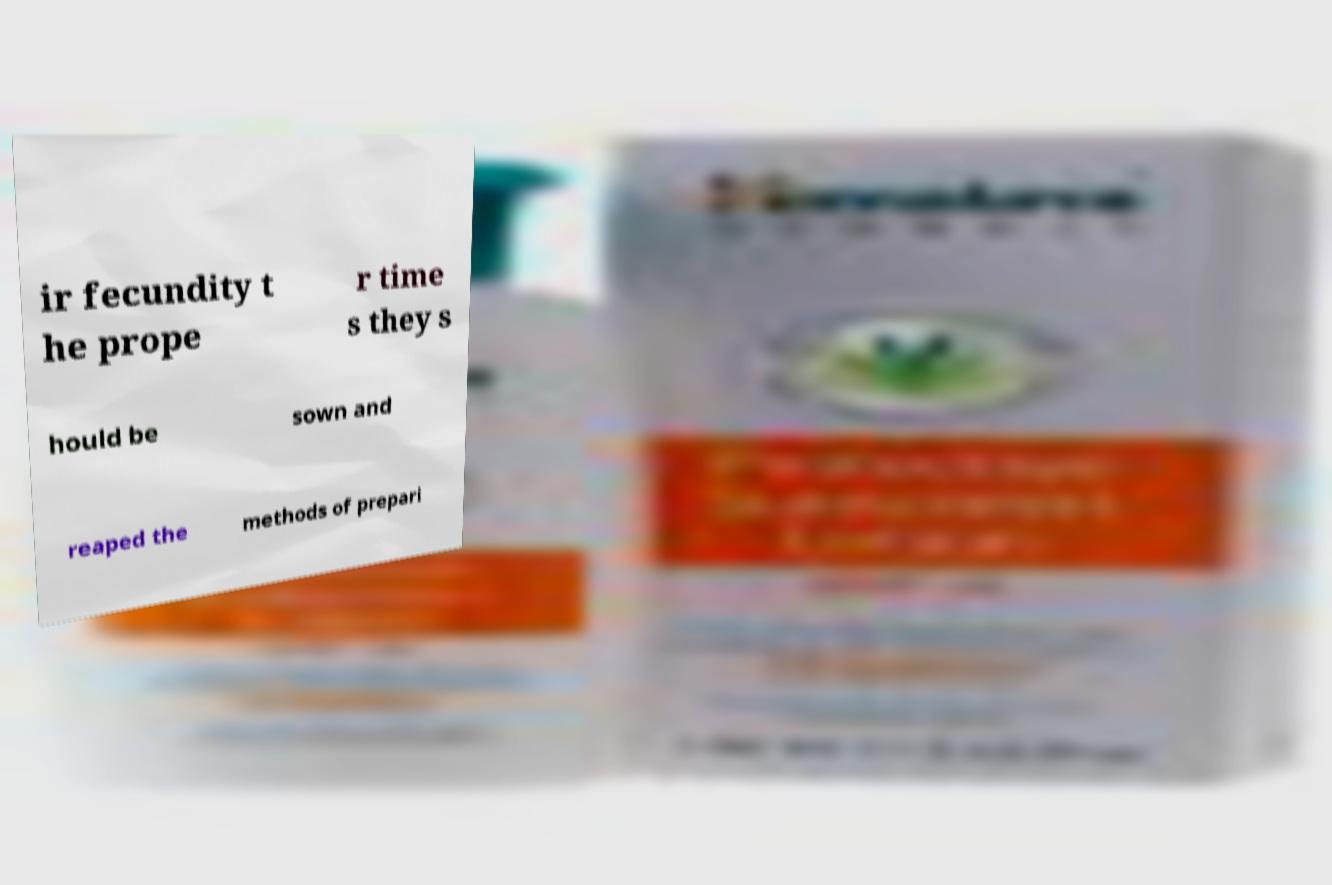There's text embedded in this image that I need extracted. Can you transcribe it verbatim? ir fecundity t he prope r time s they s hould be sown and reaped the methods of prepari 